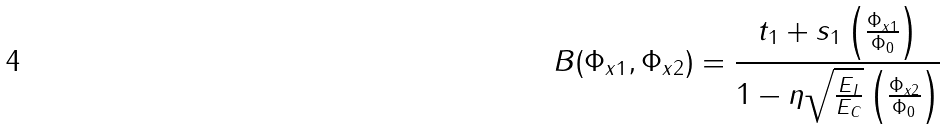Convert formula to latex. <formula><loc_0><loc_0><loc_500><loc_500>B ( \Phi _ { x 1 } , \Phi _ { x 2 } ) = \frac { t _ { 1 } + s _ { 1 } \left ( \frac { \Phi _ { x 1 } } { \Phi _ { 0 } } \right ) } { 1 - \eta \sqrt { \frac { E _ { J } } { E _ { C } } } \left ( \frac { \Phi _ { x 2 } } { \Phi _ { 0 } } \right ) }</formula> 